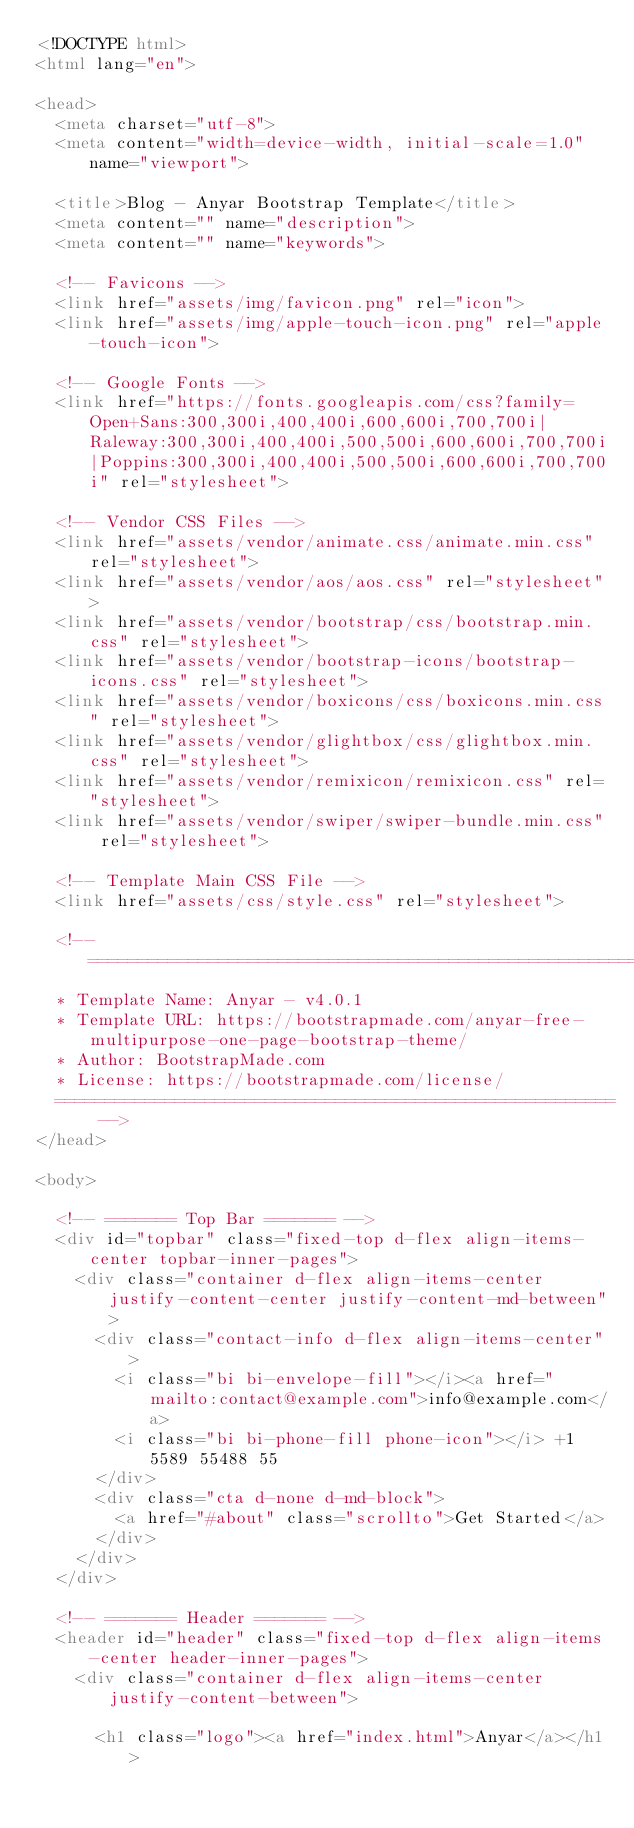<code> <loc_0><loc_0><loc_500><loc_500><_HTML_><!DOCTYPE html>
<html lang="en">

<head>
  <meta charset="utf-8">
  <meta content="width=device-width, initial-scale=1.0" name="viewport">

  <title>Blog - Anyar Bootstrap Template</title>
  <meta content="" name="description">
  <meta content="" name="keywords">

  <!-- Favicons -->
  <link href="assets/img/favicon.png" rel="icon">
  <link href="assets/img/apple-touch-icon.png" rel="apple-touch-icon">

  <!-- Google Fonts -->
  <link href="https://fonts.googleapis.com/css?family=Open+Sans:300,300i,400,400i,600,600i,700,700i|Raleway:300,300i,400,400i,500,500i,600,600i,700,700i|Poppins:300,300i,400,400i,500,500i,600,600i,700,700i" rel="stylesheet">

  <!-- Vendor CSS Files -->
  <link href="assets/vendor/animate.css/animate.min.css" rel="stylesheet">
  <link href="assets/vendor/aos/aos.css" rel="stylesheet">
  <link href="assets/vendor/bootstrap/css/bootstrap.min.css" rel="stylesheet">
  <link href="assets/vendor/bootstrap-icons/bootstrap-icons.css" rel="stylesheet">
  <link href="assets/vendor/boxicons/css/boxicons.min.css" rel="stylesheet">
  <link href="assets/vendor/glightbox/css/glightbox.min.css" rel="stylesheet">
  <link href="assets/vendor/remixicon/remixicon.css" rel="stylesheet">
  <link href="assets/vendor/swiper/swiper-bundle.min.css" rel="stylesheet">

  <!-- Template Main CSS File -->
  <link href="assets/css/style.css" rel="stylesheet">

  <!-- =======================================================
  * Template Name: Anyar - v4.0.1
  * Template URL: https://bootstrapmade.com/anyar-free-multipurpose-one-page-bootstrap-theme/
  * Author: BootstrapMade.com
  * License: https://bootstrapmade.com/license/
  ======================================================== -->
</head>

<body>

  <!-- ======= Top Bar ======= -->
  <div id="topbar" class="fixed-top d-flex align-items-center topbar-inner-pages">
    <div class="container d-flex align-items-center justify-content-center justify-content-md-between">
      <div class="contact-info d-flex align-items-center">
        <i class="bi bi-envelope-fill"></i><a href="mailto:contact@example.com">info@example.com</a>
        <i class="bi bi-phone-fill phone-icon"></i> +1 5589 55488 55
      </div>
      <div class="cta d-none d-md-block">
        <a href="#about" class="scrollto">Get Started</a>
      </div>
    </div>
  </div>

  <!-- ======= Header ======= -->
  <header id="header" class="fixed-top d-flex align-items-center header-inner-pages">
    <div class="container d-flex align-items-center justify-content-between">

      <h1 class="logo"><a href="index.html">Anyar</a></h1></code> 